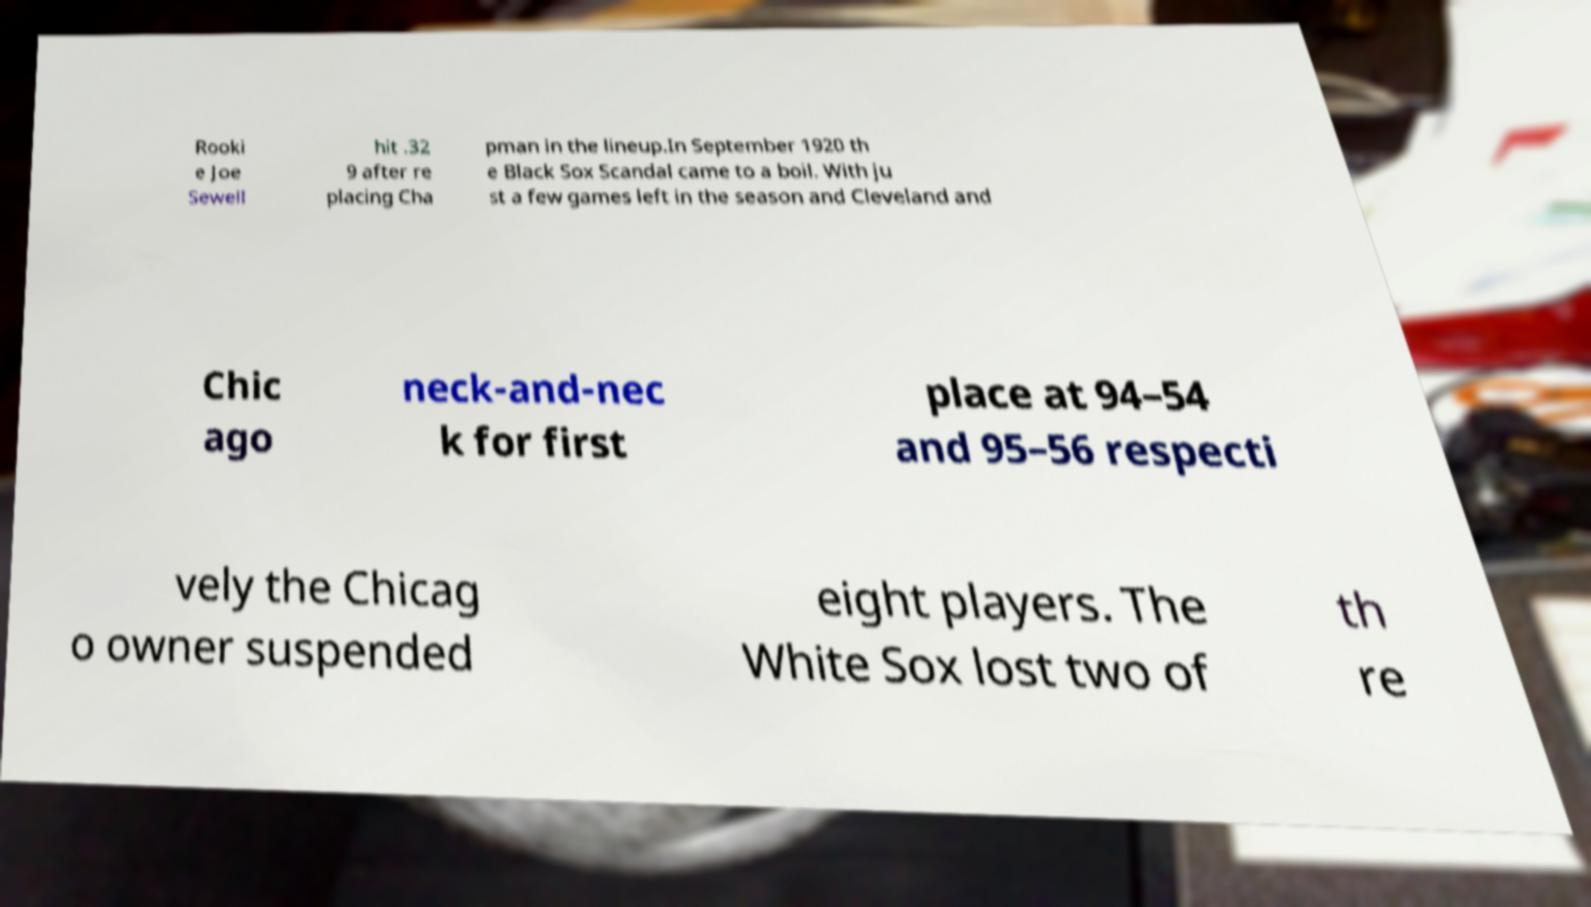Please read and relay the text visible in this image. What does it say? Rooki e Joe Sewell hit .32 9 after re placing Cha pman in the lineup.In September 1920 th e Black Sox Scandal came to a boil. With ju st a few games left in the season and Cleveland and Chic ago neck-and-nec k for first place at 94–54 and 95–56 respecti vely the Chicag o owner suspended eight players. The White Sox lost two of th re 